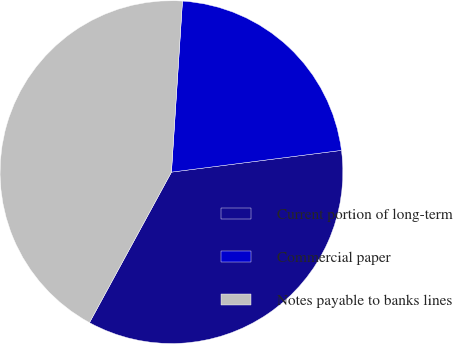Convert chart to OTSL. <chart><loc_0><loc_0><loc_500><loc_500><pie_chart><fcel>Current portion of long-term<fcel>Commercial paper<fcel>Notes payable to banks lines<nl><fcel>34.96%<fcel>21.95%<fcel>43.09%<nl></chart> 